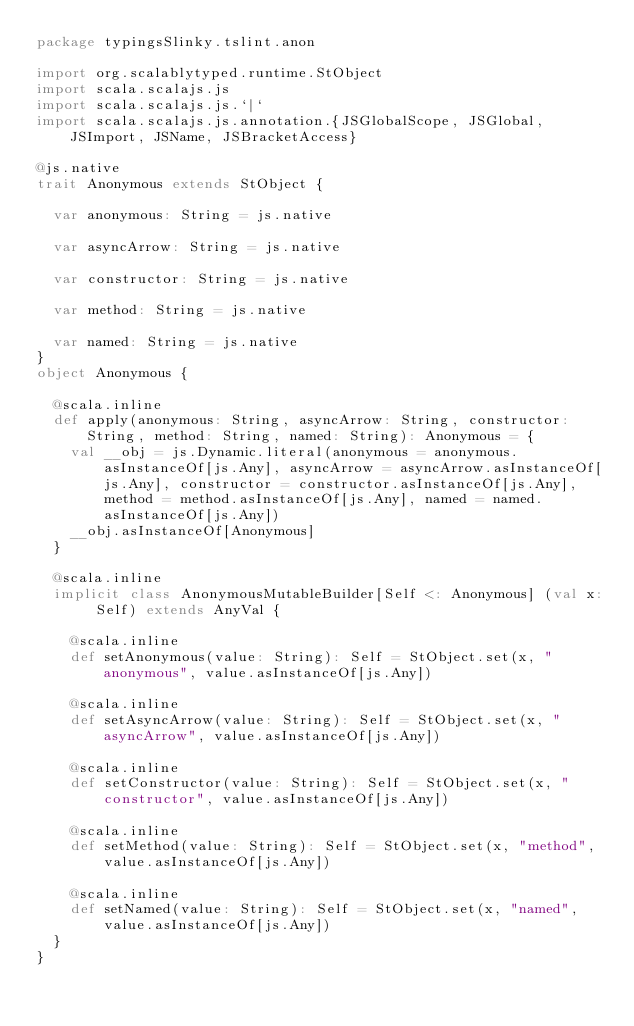Convert code to text. <code><loc_0><loc_0><loc_500><loc_500><_Scala_>package typingsSlinky.tslint.anon

import org.scalablytyped.runtime.StObject
import scala.scalajs.js
import scala.scalajs.js.`|`
import scala.scalajs.js.annotation.{JSGlobalScope, JSGlobal, JSImport, JSName, JSBracketAccess}

@js.native
trait Anonymous extends StObject {
  
  var anonymous: String = js.native
  
  var asyncArrow: String = js.native
  
  var constructor: String = js.native
  
  var method: String = js.native
  
  var named: String = js.native
}
object Anonymous {
  
  @scala.inline
  def apply(anonymous: String, asyncArrow: String, constructor: String, method: String, named: String): Anonymous = {
    val __obj = js.Dynamic.literal(anonymous = anonymous.asInstanceOf[js.Any], asyncArrow = asyncArrow.asInstanceOf[js.Any], constructor = constructor.asInstanceOf[js.Any], method = method.asInstanceOf[js.Any], named = named.asInstanceOf[js.Any])
    __obj.asInstanceOf[Anonymous]
  }
  
  @scala.inline
  implicit class AnonymousMutableBuilder[Self <: Anonymous] (val x: Self) extends AnyVal {
    
    @scala.inline
    def setAnonymous(value: String): Self = StObject.set(x, "anonymous", value.asInstanceOf[js.Any])
    
    @scala.inline
    def setAsyncArrow(value: String): Self = StObject.set(x, "asyncArrow", value.asInstanceOf[js.Any])
    
    @scala.inline
    def setConstructor(value: String): Self = StObject.set(x, "constructor", value.asInstanceOf[js.Any])
    
    @scala.inline
    def setMethod(value: String): Self = StObject.set(x, "method", value.asInstanceOf[js.Any])
    
    @scala.inline
    def setNamed(value: String): Self = StObject.set(x, "named", value.asInstanceOf[js.Any])
  }
}
</code> 